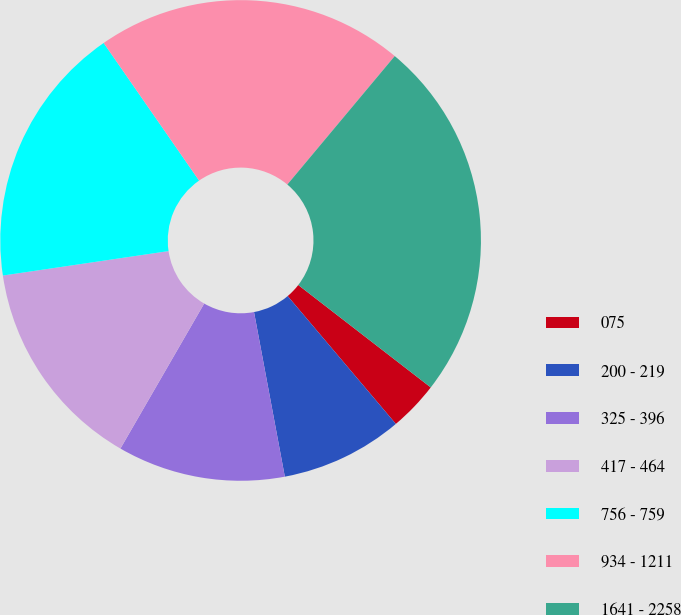<chart> <loc_0><loc_0><loc_500><loc_500><pie_chart><fcel>075<fcel>200 - 219<fcel>325 - 396<fcel>417 - 464<fcel>756 - 759<fcel>934 - 1211<fcel>1641 - 2258<nl><fcel>3.35%<fcel>8.23%<fcel>11.28%<fcel>14.33%<fcel>17.68%<fcel>20.73%<fcel>24.39%<nl></chart> 